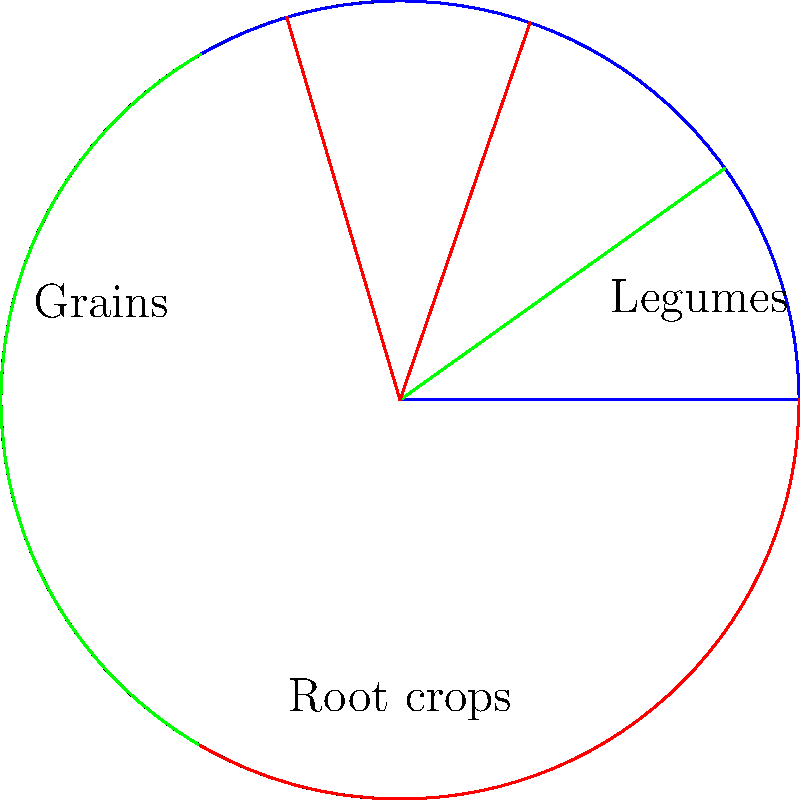The circular diagram represents a three-year crop rotation pattern. Given that this rotation significantly improves soil nitrogen content and reduces pest pressure, what is the most likely sequence of crop types, starting from the blue sector and moving clockwise? To answer this question, we need to analyze the crop rotation pattern and its effects on soil health:

1. The diagram shows a three-sector rotation, indicating a three-year cycle.

2. We're told that this rotation improves soil nitrogen content and reduces pest pressure.

3. Legumes are known for their nitrogen-fixing abilities, which improve soil nitrogen content. They should be included in the rotation.

4. Grains typically deplete soil nitrogen but benefit from the nitrogen fixed by legumes.

5. Root crops can help break pest cycles and improve soil structure.

6. The optimal sequence for soil health and pest management would be:

   a) Legumes (blue sector): Fix nitrogen in the soil
   b) Grains (green sector): Utilize the fixed nitrogen
   c) Root crops (red sector): Break pest cycles and improve soil structure

This sequence allows each crop type to benefit from the previous one while contributing to overall soil health and pest management.

The rotation then repeats, maintaining a sustainable cycle that promotes soil fertility and natural pest control, aligning with organic farming principles.
Answer: Legumes, Grains, Root crops 